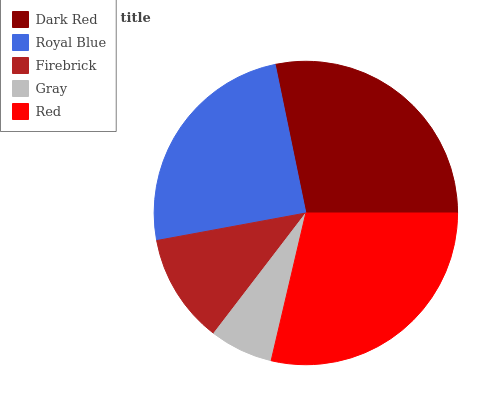Is Gray the minimum?
Answer yes or no. Yes. Is Red the maximum?
Answer yes or no. Yes. Is Royal Blue the minimum?
Answer yes or no. No. Is Royal Blue the maximum?
Answer yes or no. No. Is Dark Red greater than Royal Blue?
Answer yes or no. Yes. Is Royal Blue less than Dark Red?
Answer yes or no. Yes. Is Royal Blue greater than Dark Red?
Answer yes or no. No. Is Dark Red less than Royal Blue?
Answer yes or no. No. Is Royal Blue the high median?
Answer yes or no. Yes. Is Royal Blue the low median?
Answer yes or no. Yes. Is Red the high median?
Answer yes or no. No. Is Red the low median?
Answer yes or no. No. 